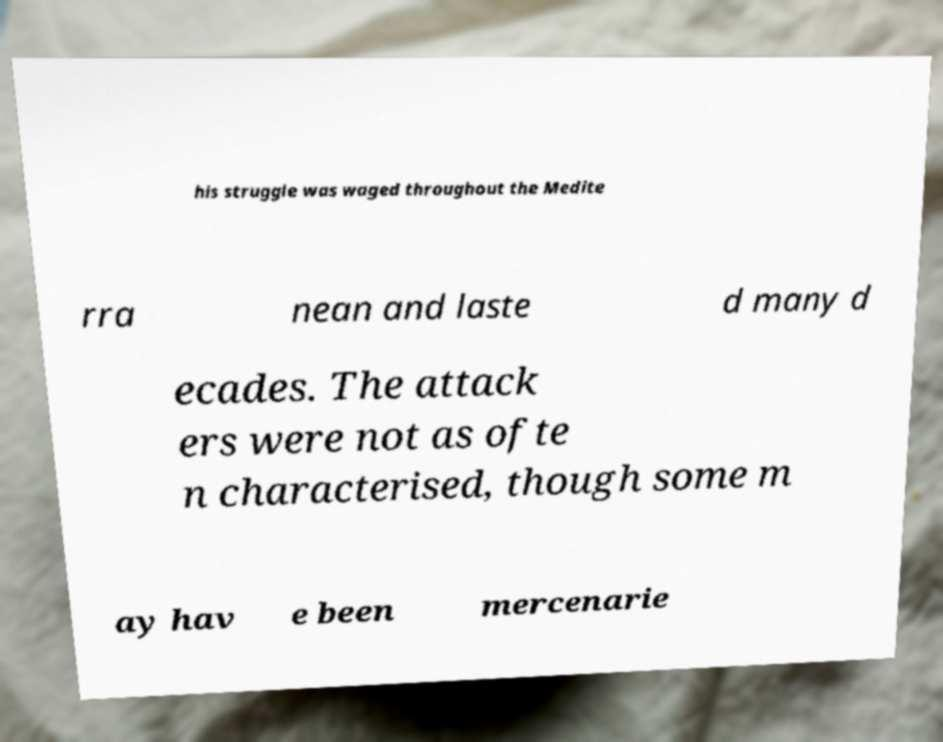I need the written content from this picture converted into text. Can you do that? his struggle was waged throughout the Medite rra nean and laste d many d ecades. The attack ers were not as ofte n characterised, though some m ay hav e been mercenarie 